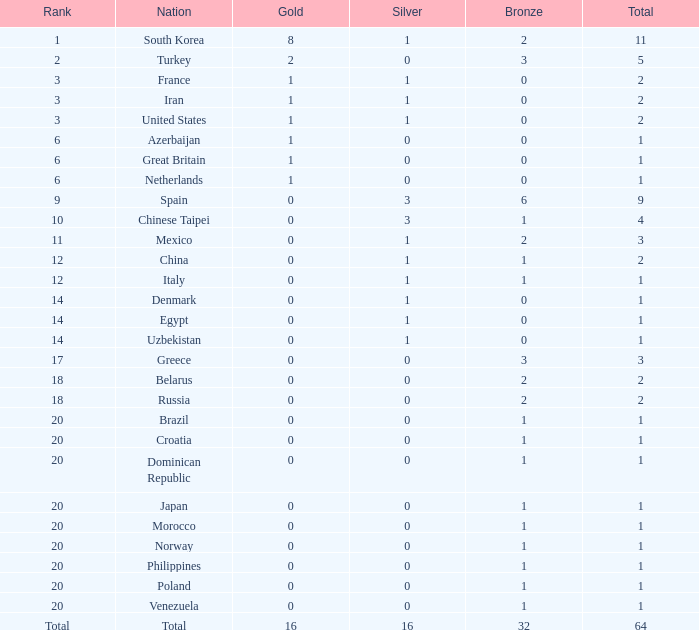What is the least number of gold medals held by a country with under 0 silver medals? None. 